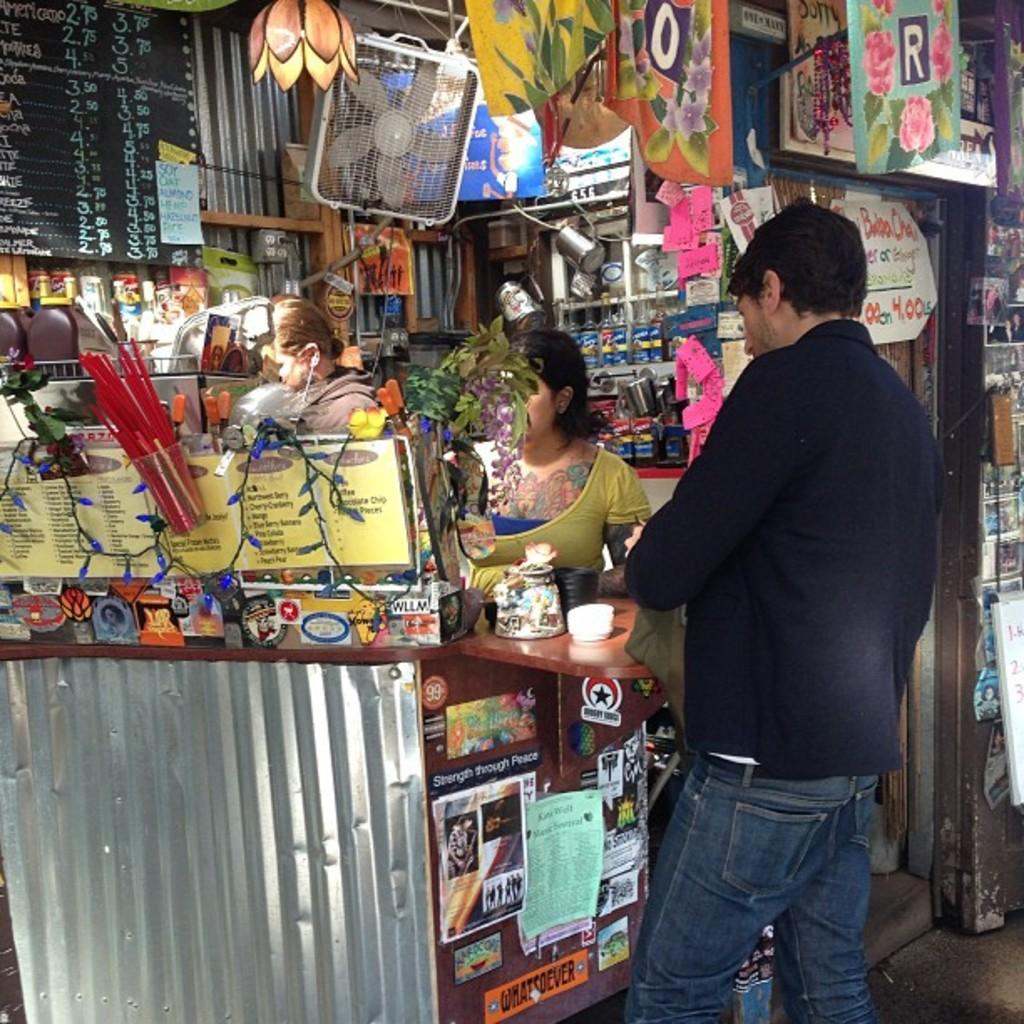<image>
Write a terse but informative summary of the picture. A man is ordering from a coffee shop that has soy, oat, almond and hemp milk available. 